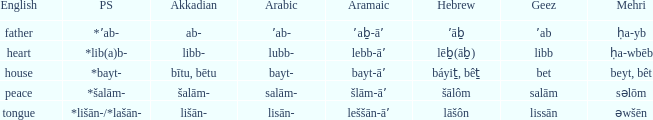If the geez is libb, what is the akkadian? Libb-. 